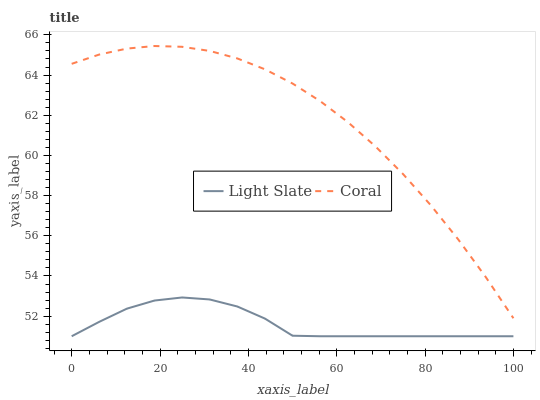Does Light Slate have the minimum area under the curve?
Answer yes or no. Yes. Does Coral have the maximum area under the curve?
Answer yes or no. Yes. Does Coral have the minimum area under the curve?
Answer yes or no. No. Is Light Slate the smoothest?
Answer yes or no. Yes. Is Coral the roughest?
Answer yes or no. Yes. Is Coral the smoothest?
Answer yes or no. No. Does Coral have the lowest value?
Answer yes or no. No. Does Coral have the highest value?
Answer yes or no. Yes. Is Light Slate less than Coral?
Answer yes or no. Yes. Is Coral greater than Light Slate?
Answer yes or no. Yes. Does Light Slate intersect Coral?
Answer yes or no. No. 